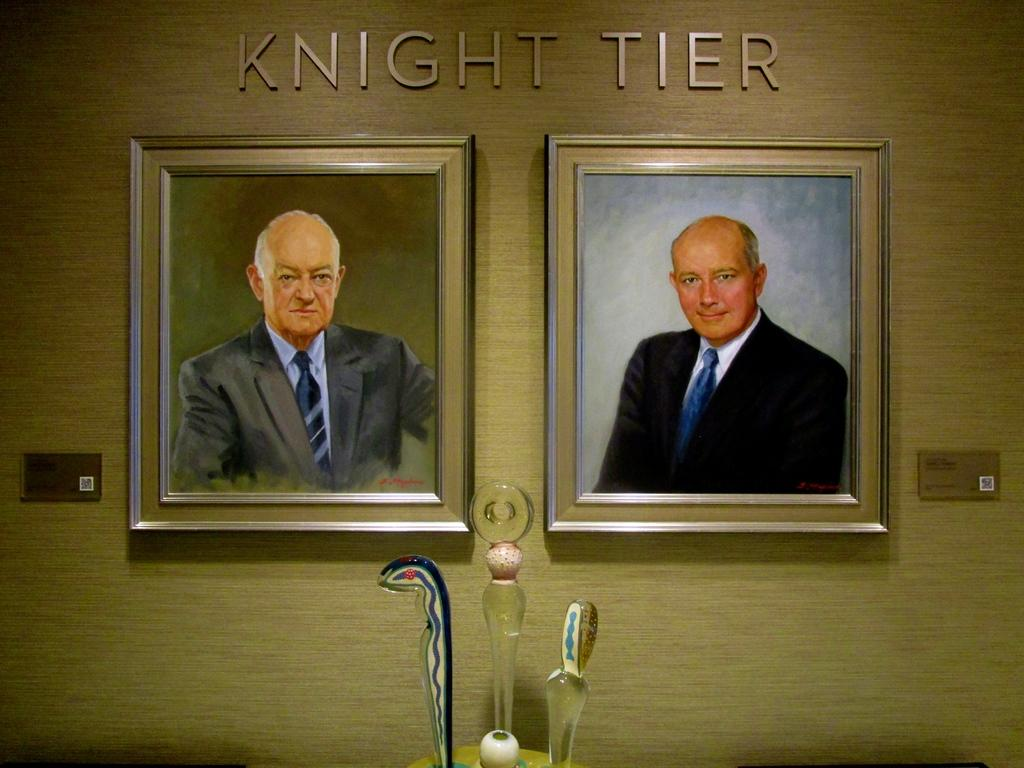<image>
Share a concise interpretation of the image provided. a couple of frames with knight tier written above them 